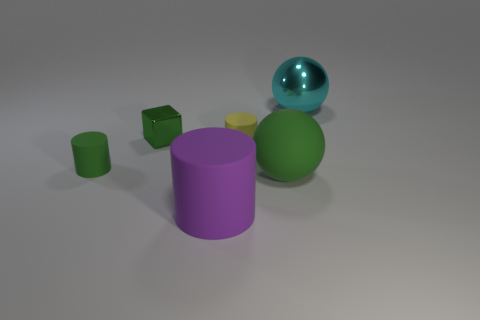How many matte objects are either small green cubes or large cubes?
Offer a very short reply. 0. Do the rubber thing on the right side of the small yellow thing and the green matte object on the left side of the tiny metal block have the same shape?
Ensure brevity in your answer.  No. There is a green cylinder; what number of objects are to the right of it?
Your answer should be compact. 5. Is there a yellow cylinder made of the same material as the large cyan ball?
Provide a short and direct response. No. What material is the cylinder that is the same size as the yellow rubber thing?
Offer a very short reply. Rubber. Are the large purple cylinder and the tiny cube made of the same material?
Provide a succinct answer. No. How many objects are big blue rubber cubes or shiny objects?
Your response must be concise. 2. There is a large rubber thing that is in front of the big green object; what is its shape?
Ensure brevity in your answer.  Cylinder. There is a big ball that is made of the same material as the small yellow cylinder; what color is it?
Ensure brevity in your answer.  Green. There is another tiny object that is the same shape as the small yellow matte thing; what material is it?
Your response must be concise. Rubber. 